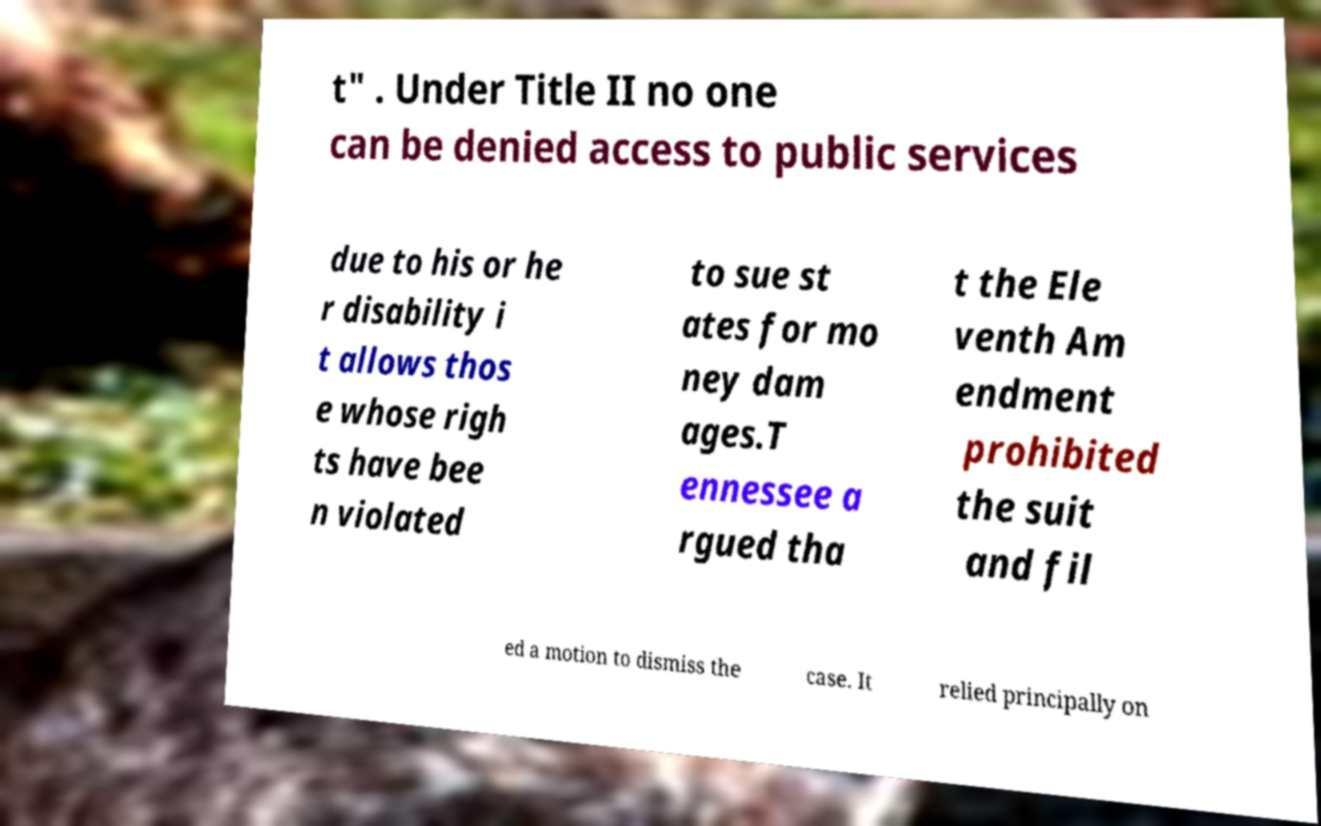I need the written content from this picture converted into text. Can you do that? t" . Under Title II no one can be denied access to public services due to his or he r disability i t allows thos e whose righ ts have bee n violated to sue st ates for mo ney dam ages.T ennessee a rgued tha t the Ele venth Am endment prohibited the suit and fil ed a motion to dismiss the case. It relied principally on 